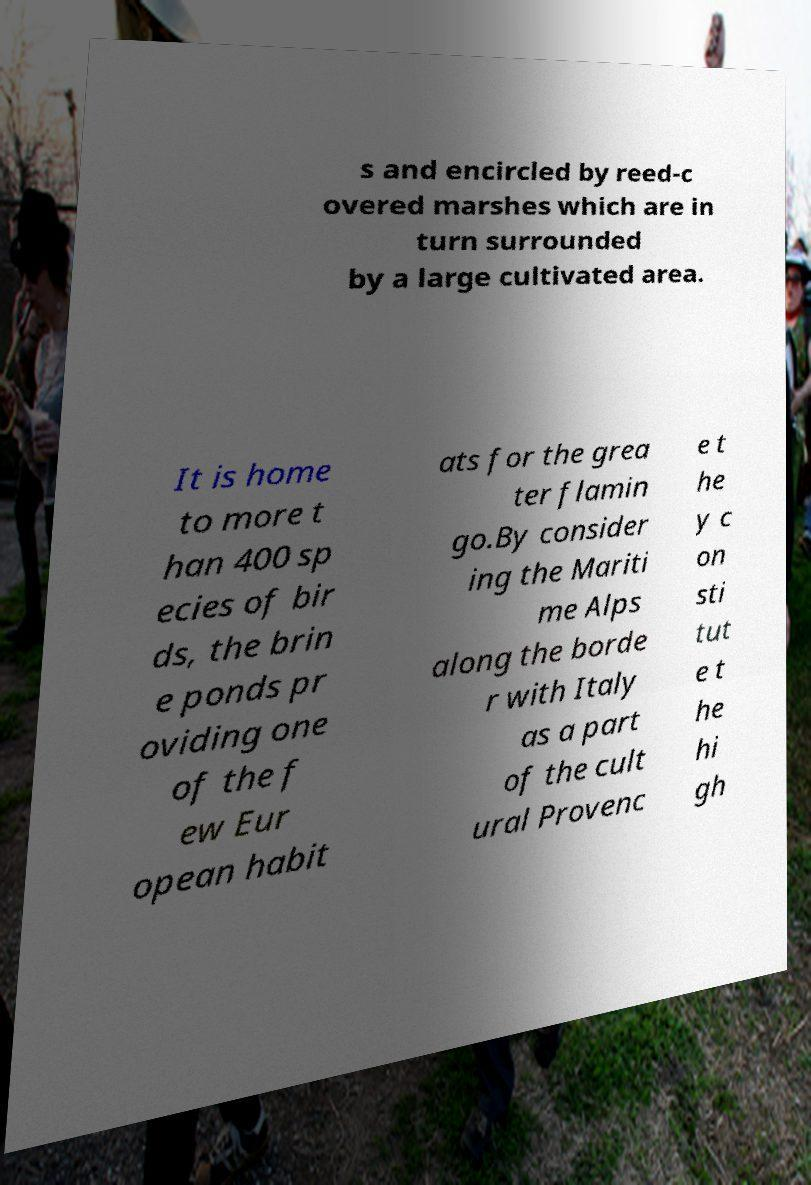Could you assist in decoding the text presented in this image and type it out clearly? s and encircled by reed-c overed marshes which are in turn surrounded by a large cultivated area. It is home to more t han 400 sp ecies of bir ds, the brin e ponds pr oviding one of the f ew Eur opean habit ats for the grea ter flamin go.By consider ing the Mariti me Alps along the borde r with Italy as a part of the cult ural Provenc e t he y c on sti tut e t he hi gh 